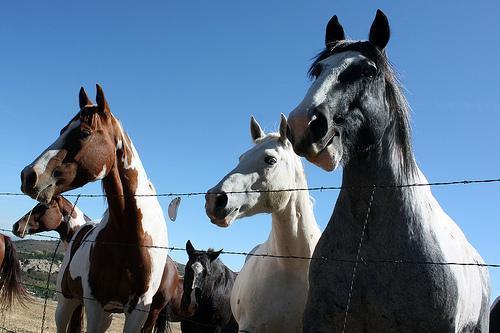How many white horses do you see?
Give a very brief answer. 1. How many horses are black and white?
Give a very brief answer. 2. 